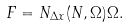Convert formula to latex. <formula><loc_0><loc_0><loc_500><loc_500>F = N _ { \Delta x } ( N , \Omega ) \Omega .</formula> 